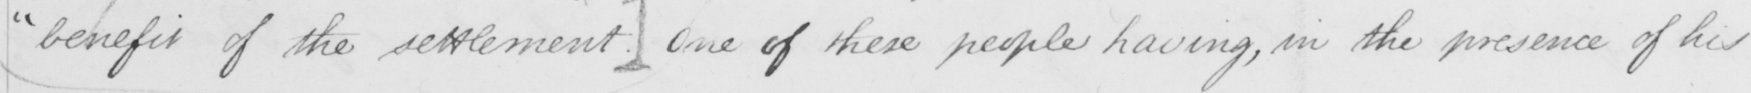What does this handwritten line say? " benefit of the settlement . ]  One of these people having , in the presence of his 